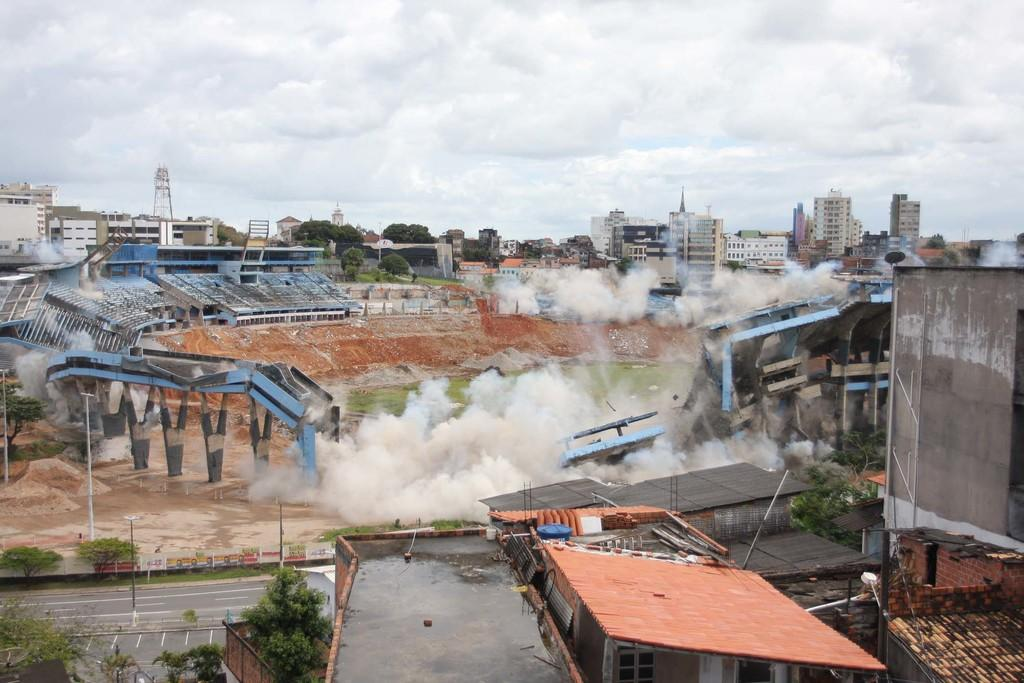What is the main structure in the image? There is a stadium in the image. What else can be seen around the stadium? Buildings and trees are visible around the stadium. What is visible at the top of the image? The sky is visible at the top of the image. What can be observed in the sky? Clouds are present in the sky. What type of behavior can be observed in the stadium during a rainy day? There is no indication of rain or behavior in the image, as it only shows the stadium, buildings, trees, and the sky. 